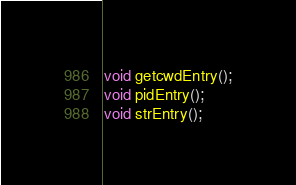Convert code to text. <code><loc_0><loc_0><loc_500><loc_500><_C_>void getcwdEntry();
void pidEntry();
void strEntry();</code> 